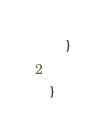Convert code to text. <code><loc_0><loc_0><loc_500><loc_500><_Java_>	}

}
</code> 